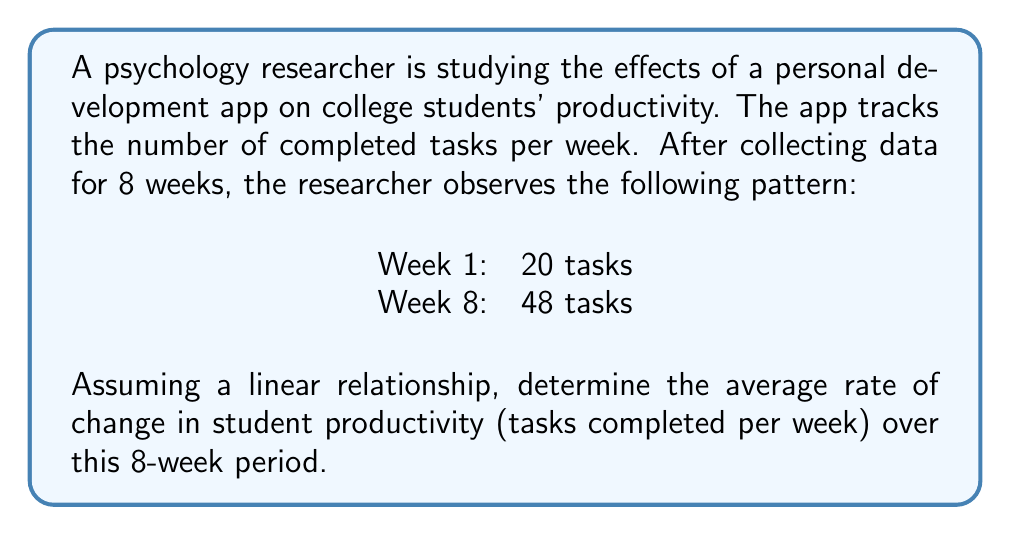Show me your answer to this math problem. To find the average rate of change in student productivity, we need to calculate the slope of the line connecting the two data points. The slope represents the change in the number of tasks completed per week.

Step 1: Identify the two points
Point 1: $(x_1, y_1) = (1, 20)$ (Week 1, 20 tasks)
Point 2: $(x_2, y_2) = (8, 48)$ (Week 8, 48 tasks)

Step 2: Use the slope formula
The slope formula is:
$$m = \frac{y_2 - y_1}{x_2 - x_1}$$

Step 3: Plug in the values
$$m = \frac{48 - 20}{8 - 1} = \frac{28}{7}$$

Step 4: Simplify
$$m = 4$$

The slope of 4 represents the average increase in the number of tasks completed per week over the 8-week period.
Answer: 4 tasks per week 